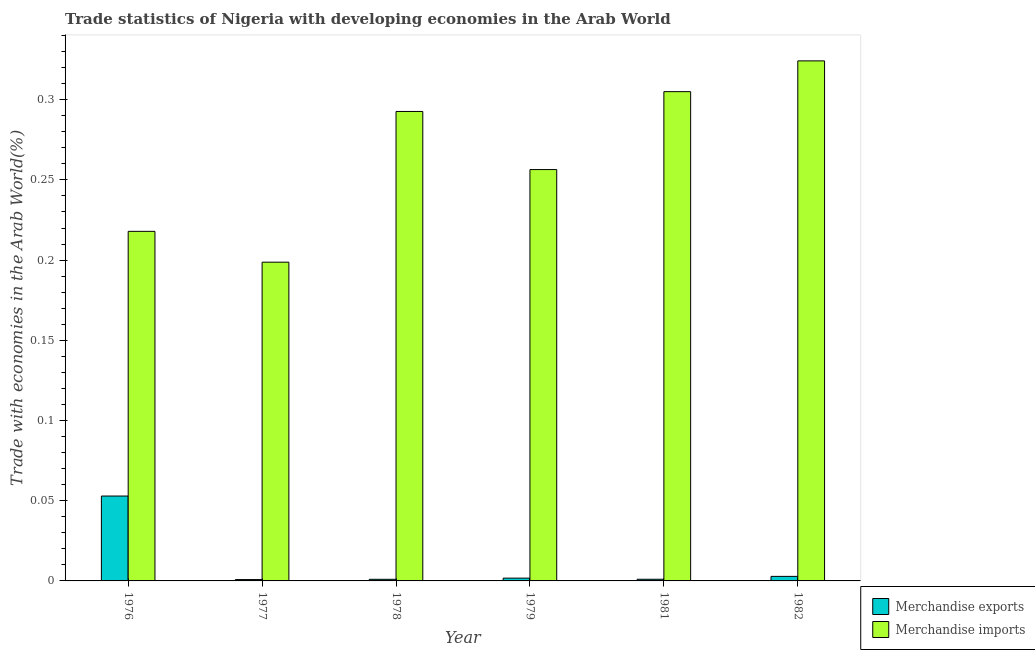How many different coloured bars are there?
Your answer should be very brief. 2. How many groups of bars are there?
Provide a succinct answer. 6. Are the number of bars per tick equal to the number of legend labels?
Ensure brevity in your answer.  Yes. What is the label of the 6th group of bars from the left?
Provide a short and direct response. 1982. In how many cases, is the number of bars for a given year not equal to the number of legend labels?
Give a very brief answer. 0. What is the merchandise imports in 1976?
Your answer should be very brief. 0.22. Across all years, what is the maximum merchandise exports?
Your answer should be compact. 0.05. Across all years, what is the minimum merchandise exports?
Keep it short and to the point. 0. In which year was the merchandise exports maximum?
Your answer should be compact. 1976. What is the total merchandise imports in the graph?
Make the answer very short. 1.6. What is the difference between the merchandise exports in 1978 and that in 1981?
Your answer should be very brief. -3.611677216894e-5. What is the difference between the merchandise exports in 1977 and the merchandise imports in 1979?
Provide a succinct answer. -0. What is the average merchandise exports per year?
Offer a very short reply. 0.01. What is the ratio of the merchandise imports in 1978 to that in 1982?
Provide a succinct answer. 0.9. What is the difference between the highest and the second highest merchandise exports?
Make the answer very short. 0.05. What is the difference between the highest and the lowest merchandise exports?
Keep it short and to the point. 0.05. Is the sum of the merchandise imports in 1976 and 1977 greater than the maximum merchandise exports across all years?
Offer a terse response. Yes. How many bars are there?
Your answer should be very brief. 12. Are all the bars in the graph horizontal?
Make the answer very short. No. How many years are there in the graph?
Your answer should be compact. 6. What is the difference between two consecutive major ticks on the Y-axis?
Give a very brief answer. 0.05. How many legend labels are there?
Your answer should be very brief. 2. How are the legend labels stacked?
Your answer should be compact. Vertical. What is the title of the graph?
Make the answer very short. Trade statistics of Nigeria with developing economies in the Arab World. What is the label or title of the X-axis?
Give a very brief answer. Year. What is the label or title of the Y-axis?
Make the answer very short. Trade with economies in the Arab World(%). What is the Trade with economies in the Arab World(%) in Merchandise exports in 1976?
Your answer should be compact. 0.05. What is the Trade with economies in the Arab World(%) in Merchandise imports in 1976?
Ensure brevity in your answer.  0.22. What is the Trade with economies in the Arab World(%) of Merchandise exports in 1977?
Offer a very short reply. 0. What is the Trade with economies in the Arab World(%) of Merchandise imports in 1977?
Your response must be concise. 0.2. What is the Trade with economies in the Arab World(%) of Merchandise exports in 1978?
Make the answer very short. 0. What is the Trade with economies in the Arab World(%) in Merchandise imports in 1978?
Your answer should be compact. 0.29. What is the Trade with economies in the Arab World(%) of Merchandise exports in 1979?
Keep it short and to the point. 0. What is the Trade with economies in the Arab World(%) in Merchandise imports in 1979?
Give a very brief answer. 0.26. What is the Trade with economies in the Arab World(%) in Merchandise exports in 1981?
Offer a very short reply. 0. What is the Trade with economies in the Arab World(%) of Merchandise imports in 1981?
Keep it short and to the point. 0.31. What is the Trade with economies in the Arab World(%) of Merchandise exports in 1982?
Offer a very short reply. 0. What is the Trade with economies in the Arab World(%) in Merchandise imports in 1982?
Offer a very short reply. 0.32. Across all years, what is the maximum Trade with economies in the Arab World(%) in Merchandise exports?
Keep it short and to the point. 0.05. Across all years, what is the maximum Trade with economies in the Arab World(%) of Merchandise imports?
Offer a terse response. 0.32. Across all years, what is the minimum Trade with economies in the Arab World(%) in Merchandise exports?
Make the answer very short. 0. Across all years, what is the minimum Trade with economies in the Arab World(%) of Merchandise imports?
Provide a short and direct response. 0.2. What is the total Trade with economies in the Arab World(%) of Merchandise exports in the graph?
Give a very brief answer. 0.06. What is the total Trade with economies in the Arab World(%) in Merchandise imports in the graph?
Provide a short and direct response. 1.59. What is the difference between the Trade with economies in the Arab World(%) of Merchandise exports in 1976 and that in 1977?
Ensure brevity in your answer.  0.05. What is the difference between the Trade with economies in the Arab World(%) in Merchandise imports in 1976 and that in 1977?
Your response must be concise. 0.02. What is the difference between the Trade with economies in the Arab World(%) in Merchandise exports in 1976 and that in 1978?
Offer a very short reply. 0.05. What is the difference between the Trade with economies in the Arab World(%) in Merchandise imports in 1976 and that in 1978?
Offer a terse response. -0.07. What is the difference between the Trade with economies in the Arab World(%) of Merchandise exports in 1976 and that in 1979?
Provide a succinct answer. 0.05. What is the difference between the Trade with economies in the Arab World(%) of Merchandise imports in 1976 and that in 1979?
Give a very brief answer. -0.04. What is the difference between the Trade with economies in the Arab World(%) in Merchandise exports in 1976 and that in 1981?
Provide a succinct answer. 0.05. What is the difference between the Trade with economies in the Arab World(%) in Merchandise imports in 1976 and that in 1981?
Make the answer very short. -0.09. What is the difference between the Trade with economies in the Arab World(%) in Merchandise exports in 1976 and that in 1982?
Ensure brevity in your answer.  0.05. What is the difference between the Trade with economies in the Arab World(%) of Merchandise imports in 1976 and that in 1982?
Keep it short and to the point. -0.11. What is the difference between the Trade with economies in the Arab World(%) in Merchandise exports in 1977 and that in 1978?
Give a very brief answer. -0. What is the difference between the Trade with economies in the Arab World(%) in Merchandise imports in 1977 and that in 1978?
Keep it short and to the point. -0.09. What is the difference between the Trade with economies in the Arab World(%) of Merchandise exports in 1977 and that in 1979?
Your answer should be very brief. -0. What is the difference between the Trade with economies in the Arab World(%) of Merchandise imports in 1977 and that in 1979?
Offer a very short reply. -0.06. What is the difference between the Trade with economies in the Arab World(%) of Merchandise exports in 1977 and that in 1981?
Make the answer very short. -0. What is the difference between the Trade with economies in the Arab World(%) of Merchandise imports in 1977 and that in 1981?
Offer a very short reply. -0.11. What is the difference between the Trade with economies in the Arab World(%) in Merchandise exports in 1977 and that in 1982?
Your response must be concise. -0. What is the difference between the Trade with economies in the Arab World(%) of Merchandise imports in 1977 and that in 1982?
Your answer should be compact. -0.13. What is the difference between the Trade with economies in the Arab World(%) of Merchandise exports in 1978 and that in 1979?
Offer a terse response. -0. What is the difference between the Trade with economies in the Arab World(%) of Merchandise imports in 1978 and that in 1979?
Make the answer very short. 0.04. What is the difference between the Trade with economies in the Arab World(%) of Merchandise exports in 1978 and that in 1981?
Ensure brevity in your answer.  -0. What is the difference between the Trade with economies in the Arab World(%) of Merchandise imports in 1978 and that in 1981?
Keep it short and to the point. -0.01. What is the difference between the Trade with economies in the Arab World(%) in Merchandise exports in 1978 and that in 1982?
Your answer should be very brief. -0. What is the difference between the Trade with economies in the Arab World(%) of Merchandise imports in 1978 and that in 1982?
Give a very brief answer. -0.03. What is the difference between the Trade with economies in the Arab World(%) of Merchandise exports in 1979 and that in 1981?
Your answer should be compact. 0. What is the difference between the Trade with economies in the Arab World(%) in Merchandise imports in 1979 and that in 1981?
Ensure brevity in your answer.  -0.05. What is the difference between the Trade with economies in the Arab World(%) in Merchandise exports in 1979 and that in 1982?
Your answer should be very brief. -0. What is the difference between the Trade with economies in the Arab World(%) of Merchandise imports in 1979 and that in 1982?
Your response must be concise. -0.07. What is the difference between the Trade with economies in the Arab World(%) in Merchandise exports in 1981 and that in 1982?
Ensure brevity in your answer.  -0. What is the difference between the Trade with economies in the Arab World(%) in Merchandise imports in 1981 and that in 1982?
Provide a short and direct response. -0.02. What is the difference between the Trade with economies in the Arab World(%) of Merchandise exports in 1976 and the Trade with economies in the Arab World(%) of Merchandise imports in 1977?
Give a very brief answer. -0.15. What is the difference between the Trade with economies in the Arab World(%) in Merchandise exports in 1976 and the Trade with economies in the Arab World(%) in Merchandise imports in 1978?
Offer a very short reply. -0.24. What is the difference between the Trade with economies in the Arab World(%) in Merchandise exports in 1976 and the Trade with economies in the Arab World(%) in Merchandise imports in 1979?
Keep it short and to the point. -0.2. What is the difference between the Trade with economies in the Arab World(%) of Merchandise exports in 1976 and the Trade with economies in the Arab World(%) of Merchandise imports in 1981?
Ensure brevity in your answer.  -0.25. What is the difference between the Trade with economies in the Arab World(%) in Merchandise exports in 1976 and the Trade with economies in the Arab World(%) in Merchandise imports in 1982?
Give a very brief answer. -0.27. What is the difference between the Trade with economies in the Arab World(%) of Merchandise exports in 1977 and the Trade with economies in the Arab World(%) of Merchandise imports in 1978?
Provide a succinct answer. -0.29. What is the difference between the Trade with economies in the Arab World(%) of Merchandise exports in 1977 and the Trade with economies in the Arab World(%) of Merchandise imports in 1979?
Ensure brevity in your answer.  -0.26. What is the difference between the Trade with economies in the Arab World(%) in Merchandise exports in 1977 and the Trade with economies in the Arab World(%) in Merchandise imports in 1981?
Provide a short and direct response. -0.3. What is the difference between the Trade with economies in the Arab World(%) in Merchandise exports in 1977 and the Trade with economies in the Arab World(%) in Merchandise imports in 1982?
Offer a very short reply. -0.32. What is the difference between the Trade with economies in the Arab World(%) of Merchandise exports in 1978 and the Trade with economies in the Arab World(%) of Merchandise imports in 1979?
Make the answer very short. -0.26. What is the difference between the Trade with economies in the Arab World(%) in Merchandise exports in 1978 and the Trade with economies in the Arab World(%) in Merchandise imports in 1981?
Keep it short and to the point. -0.3. What is the difference between the Trade with economies in the Arab World(%) of Merchandise exports in 1978 and the Trade with economies in the Arab World(%) of Merchandise imports in 1982?
Give a very brief answer. -0.32. What is the difference between the Trade with economies in the Arab World(%) in Merchandise exports in 1979 and the Trade with economies in the Arab World(%) in Merchandise imports in 1981?
Keep it short and to the point. -0.3. What is the difference between the Trade with economies in the Arab World(%) of Merchandise exports in 1979 and the Trade with economies in the Arab World(%) of Merchandise imports in 1982?
Give a very brief answer. -0.32. What is the difference between the Trade with economies in the Arab World(%) of Merchandise exports in 1981 and the Trade with economies in the Arab World(%) of Merchandise imports in 1982?
Make the answer very short. -0.32. What is the average Trade with economies in the Arab World(%) in Merchandise exports per year?
Provide a short and direct response. 0.01. What is the average Trade with economies in the Arab World(%) of Merchandise imports per year?
Keep it short and to the point. 0.27. In the year 1976, what is the difference between the Trade with economies in the Arab World(%) in Merchandise exports and Trade with economies in the Arab World(%) in Merchandise imports?
Provide a succinct answer. -0.17. In the year 1977, what is the difference between the Trade with economies in the Arab World(%) in Merchandise exports and Trade with economies in the Arab World(%) in Merchandise imports?
Offer a terse response. -0.2. In the year 1978, what is the difference between the Trade with economies in the Arab World(%) of Merchandise exports and Trade with economies in the Arab World(%) of Merchandise imports?
Your response must be concise. -0.29. In the year 1979, what is the difference between the Trade with economies in the Arab World(%) of Merchandise exports and Trade with economies in the Arab World(%) of Merchandise imports?
Your answer should be compact. -0.25. In the year 1981, what is the difference between the Trade with economies in the Arab World(%) in Merchandise exports and Trade with economies in the Arab World(%) in Merchandise imports?
Make the answer very short. -0.3. In the year 1982, what is the difference between the Trade with economies in the Arab World(%) in Merchandise exports and Trade with economies in the Arab World(%) in Merchandise imports?
Offer a terse response. -0.32. What is the ratio of the Trade with economies in the Arab World(%) of Merchandise exports in 1976 to that in 1977?
Provide a short and direct response. 62.57. What is the ratio of the Trade with economies in the Arab World(%) of Merchandise imports in 1976 to that in 1977?
Ensure brevity in your answer.  1.1. What is the ratio of the Trade with economies in the Arab World(%) in Merchandise exports in 1976 to that in 1978?
Give a very brief answer. 52.69. What is the ratio of the Trade with economies in the Arab World(%) in Merchandise imports in 1976 to that in 1978?
Make the answer very short. 0.74. What is the ratio of the Trade with economies in the Arab World(%) of Merchandise exports in 1976 to that in 1979?
Your response must be concise. 30.38. What is the ratio of the Trade with economies in the Arab World(%) in Merchandise imports in 1976 to that in 1979?
Your answer should be very brief. 0.85. What is the ratio of the Trade with economies in the Arab World(%) of Merchandise exports in 1976 to that in 1981?
Your answer should be very brief. 50.86. What is the ratio of the Trade with economies in the Arab World(%) in Merchandise imports in 1976 to that in 1981?
Give a very brief answer. 0.71. What is the ratio of the Trade with economies in the Arab World(%) of Merchandise exports in 1976 to that in 1982?
Offer a terse response. 18.73. What is the ratio of the Trade with economies in the Arab World(%) in Merchandise imports in 1976 to that in 1982?
Keep it short and to the point. 0.67. What is the ratio of the Trade with economies in the Arab World(%) of Merchandise exports in 1977 to that in 1978?
Your answer should be very brief. 0.84. What is the ratio of the Trade with economies in the Arab World(%) in Merchandise imports in 1977 to that in 1978?
Your answer should be compact. 0.68. What is the ratio of the Trade with economies in the Arab World(%) in Merchandise exports in 1977 to that in 1979?
Keep it short and to the point. 0.49. What is the ratio of the Trade with economies in the Arab World(%) of Merchandise imports in 1977 to that in 1979?
Give a very brief answer. 0.77. What is the ratio of the Trade with economies in the Arab World(%) in Merchandise exports in 1977 to that in 1981?
Your response must be concise. 0.81. What is the ratio of the Trade with economies in the Arab World(%) in Merchandise imports in 1977 to that in 1981?
Ensure brevity in your answer.  0.65. What is the ratio of the Trade with economies in the Arab World(%) of Merchandise exports in 1977 to that in 1982?
Your answer should be very brief. 0.3. What is the ratio of the Trade with economies in the Arab World(%) in Merchandise imports in 1977 to that in 1982?
Your answer should be compact. 0.61. What is the ratio of the Trade with economies in the Arab World(%) in Merchandise exports in 1978 to that in 1979?
Your answer should be very brief. 0.58. What is the ratio of the Trade with economies in the Arab World(%) of Merchandise imports in 1978 to that in 1979?
Make the answer very short. 1.14. What is the ratio of the Trade with economies in the Arab World(%) in Merchandise exports in 1978 to that in 1981?
Keep it short and to the point. 0.97. What is the ratio of the Trade with economies in the Arab World(%) of Merchandise imports in 1978 to that in 1981?
Keep it short and to the point. 0.96. What is the ratio of the Trade with economies in the Arab World(%) in Merchandise exports in 1978 to that in 1982?
Provide a short and direct response. 0.36. What is the ratio of the Trade with economies in the Arab World(%) in Merchandise imports in 1978 to that in 1982?
Your answer should be compact. 0.9. What is the ratio of the Trade with economies in the Arab World(%) of Merchandise exports in 1979 to that in 1981?
Your response must be concise. 1.67. What is the ratio of the Trade with economies in the Arab World(%) of Merchandise imports in 1979 to that in 1981?
Ensure brevity in your answer.  0.84. What is the ratio of the Trade with economies in the Arab World(%) of Merchandise exports in 1979 to that in 1982?
Your response must be concise. 0.62. What is the ratio of the Trade with economies in the Arab World(%) of Merchandise imports in 1979 to that in 1982?
Keep it short and to the point. 0.79. What is the ratio of the Trade with economies in the Arab World(%) in Merchandise exports in 1981 to that in 1982?
Offer a very short reply. 0.37. What is the ratio of the Trade with economies in the Arab World(%) in Merchandise imports in 1981 to that in 1982?
Offer a terse response. 0.94. What is the difference between the highest and the second highest Trade with economies in the Arab World(%) in Merchandise exports?
Your answer should be very brief. 0.05. What is the difference between the highest and the second highest Trade with economies in the Arab World(%) of Merchandise imports?
Your response must be concise. 0.02. What is the difference between the highest and the lowest Trade with economies in the Arab World(%) in Merchandise exports?
Offer a very short reply. 0.05. What is the difference between the highest and the lowest Trade with economies in the Arab World(%) of Merchandise imports?
Make the answer very short. 0.13. 